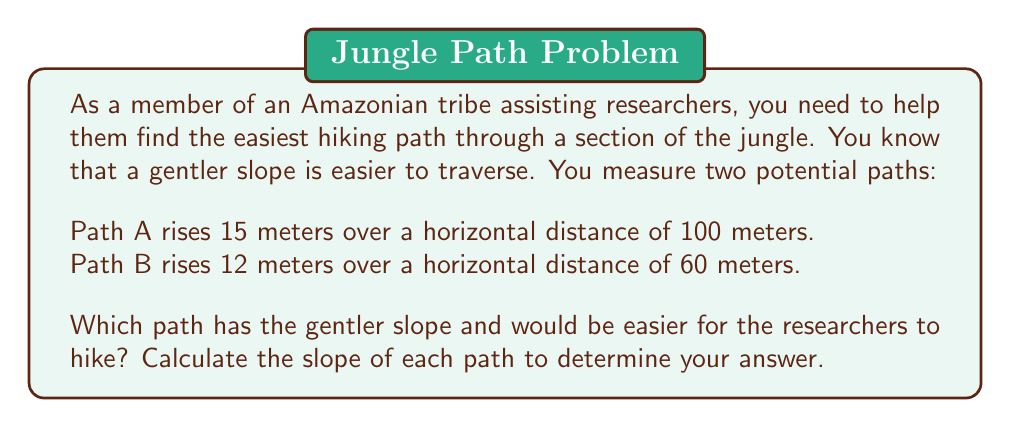Provide a solution to this math problem. To solve this problem, we need to calculate the slope of each path and compare them. The path with the smaller slope will be gentler and easier to hike.

The formula for slope is:

$$ \text{Slope} = \frac{\text{Rise}}{\text{Run}} = \frac{\text{Vertical change}}{\text{Horizontal change}} $$

For Path A:
$$ \text{Slope}_A = \frac{15 \text{ meters}}{100 \text{ meters}} = 0.15 $$

For Path B:
$$ \text{Slope}_B = \frac{12 \text{ meters}}{60 \text{ meters}} = 0.2 $$

To express these as percentages, we multiply by 100:

Path A slope: $0.15 \times 100 = 15\%$
Path B slope: $0.2 \times 100 = 20\%$

Comparing the two slopes:
$0.15 < 0.2$ or $15\% < 20\%$

Therefore, Path A has the gentler slope and would be easier for the researchers to hike.
Answer: Path A has the gentler slope with a 15% grade, compared to Path B's 20% grade. Path A would be easier for the researchers to hike. 